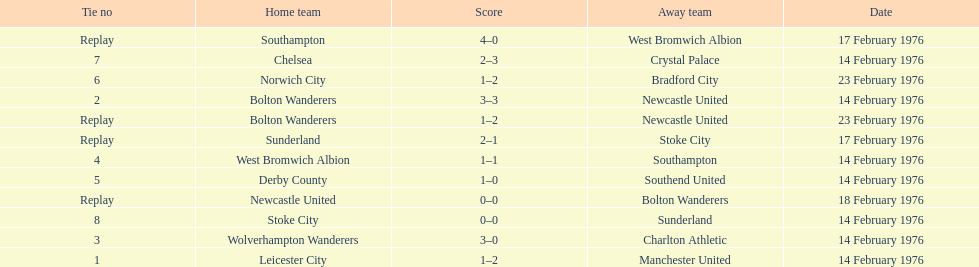How many games did the bolton wanderers and newcastle united play before there was a definitive winner in the fifth round proper? 3. 